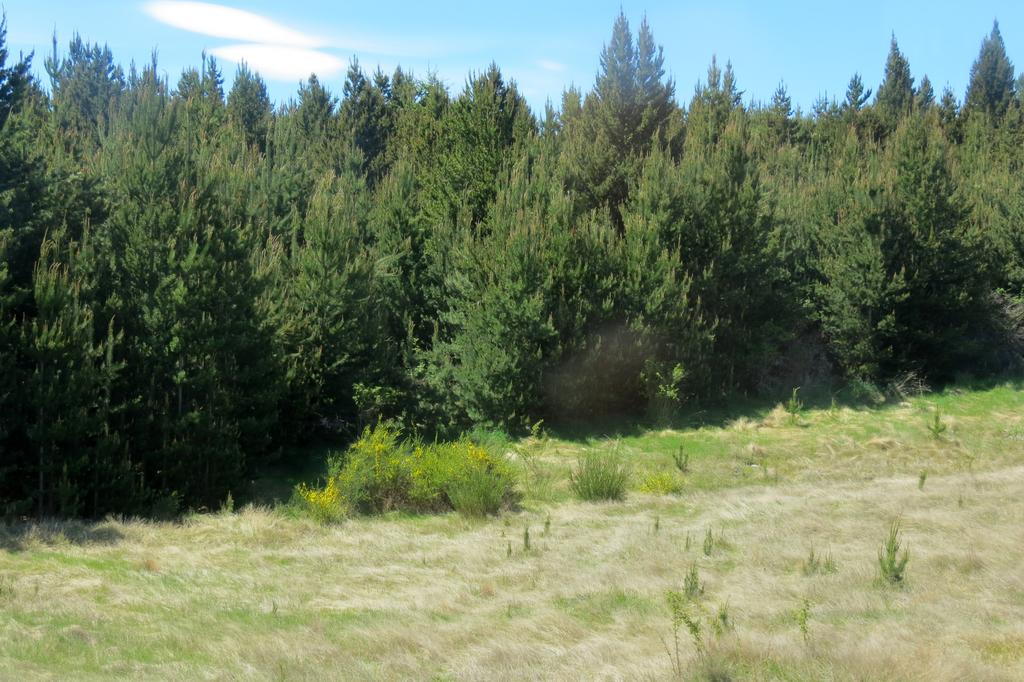What type of vegetation can be seen in the image? There is grass, plants, and trees in the image. What part of the natural environment is visible in the image? The sky is visible in the background of the image. What type of bun is being used to cook in the image? There is no bun or cooking appliance present in the image; it features grass, plants, trees, and the sky. 